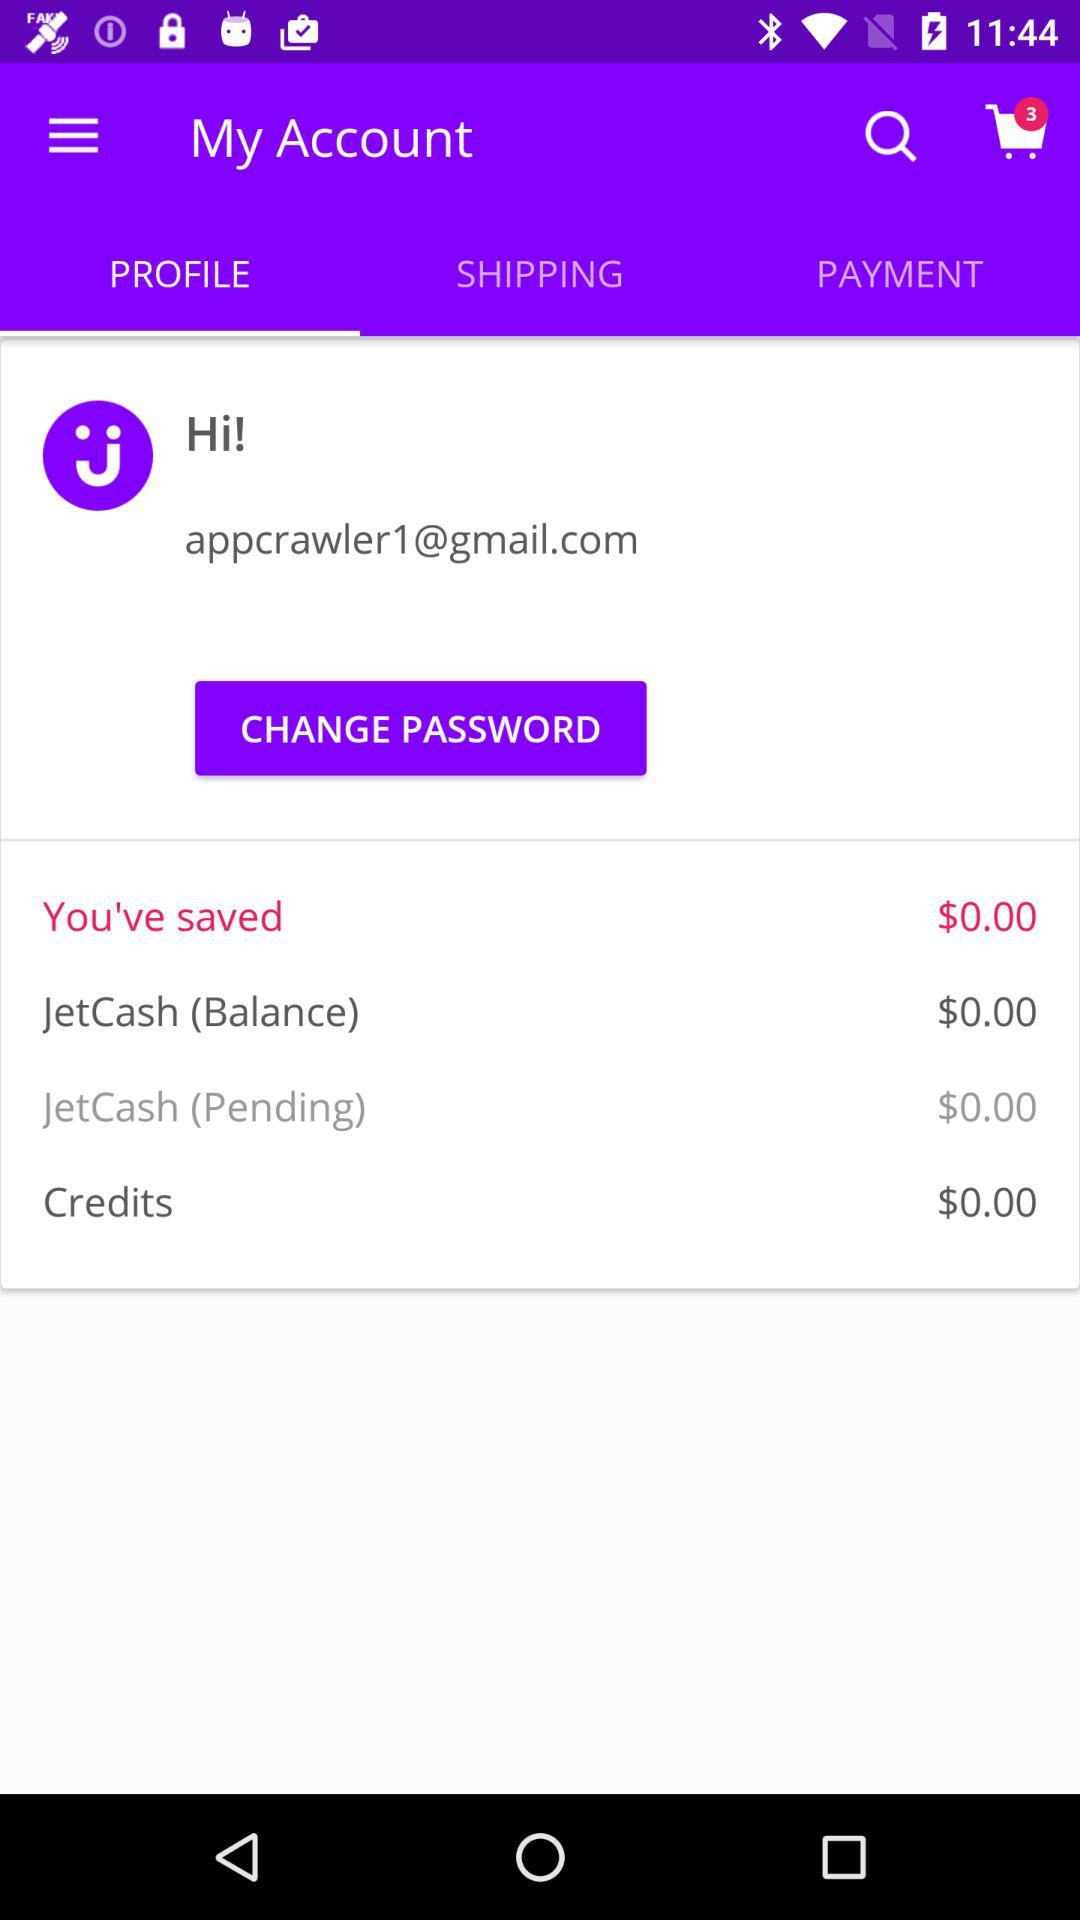How many items are in the cart? There are 3 items. 